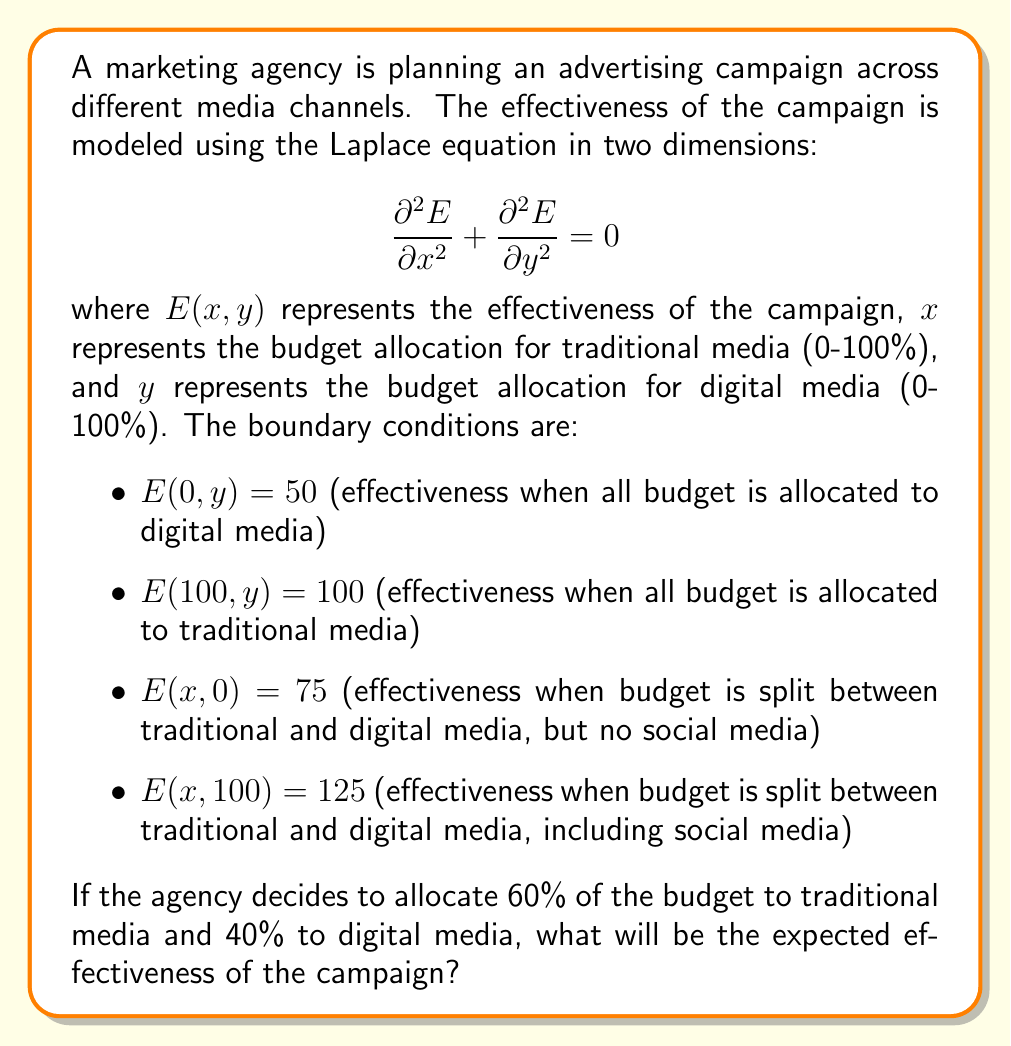Provide a solution to this math problem. To solve this problem, we need to use the solution to the Laplace equation in two dimensions with the given boundary conditions. The general solution for this type of problem is:

$$E(x,y) = A + Bx + Cy + Dxy$$

where A, B, C, and D are constants to be determined from the boundary conditions.

Step 1: Apply the boundary conditions

1. $E(0,y) = 50$ implies $A + Cy = 50$ for all y
2. $E(100,y) = 100$ implies $A + 100B + Cy + 100Dy = 100$ for all y
3. $E(x,0) = 75$ implies $A + Bx = 75$ for all x
4. $E(x,100) = 125$ implies $A + Bx + 100C + 100Dx = 125$ for all x

Step 2: Solve for the constants

From conditions 1 and 3:
$A = 50$ and $C = 0$
$B = 0.25$ and $D = 0.005$

Step 3: Write the final equation

$$E(x,y) = 50 + 0.25x + 0.005xy$$

Step 4: Calculate the effectiveness for the given allocation

For 60% traditional media (x = 60) and 40% digital media (y = 40):

$$E(60,40) = 50 + 0.25(60) + 0.005(60)(40)$$
$$E(60,40) = 50 + 15 + 12$$
$$E(60,40) = 77$$

Therefore, the expected effectiveness of the campaign with this budget allocation is 77.
Answer: 77 